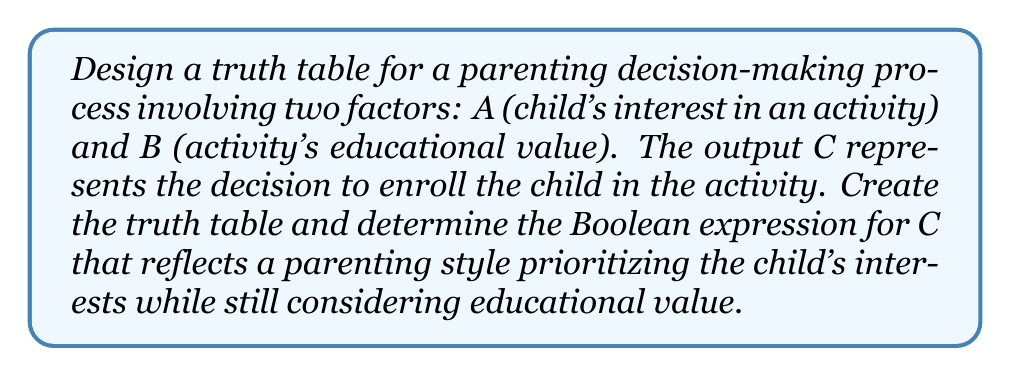Help me with this question. Let's approach this step-by-step:

1) First, we need to create a truth table with inputs A and B, and output C:

   | A | B | C |
   |---|---|---|
   | 0 | 0 | ? |
   | 0 | 1 | ? |
   | 1 | 0 | ? |
   | 1 | 1 | ? |

2) Now, let's fill in the C column based on our parenting style:
   - If A = 1 (child is interested), we'll generally enroll (C = 1), regardless of B.
   - If A = 0 (child isn't interested), we'll only enroll if B = 1 (high educational value).

   | A | B | C |
   |---|---|---|
   | 0 | 0 | 0 |
   | 0 | 1 | 1 |
   | 1 | 0 | 1 |
   | 1 | 1 | 1 |

3) From this truth table, we can derive the Boolean expression for C:

   $$C = A + B$$

   This is because C is true (1) when either A is true OR B is true (or both).

4) We can verify this using the distributive law:

   $$C = A + B = (A \cdot 1) + (0 \cdot B) + (A \cdot B)$$

   This covers all cases where C = 1 in our truth table.

5) This expression, $$C = A + B$$, represents a parenting style that enrolls the child in an activity if either the child is interested OR the activity has high educational value, aligning with the persona's belief in prioritizing the child's interests while still considering educational aspects.
Answer: $$C = A + B$$ 